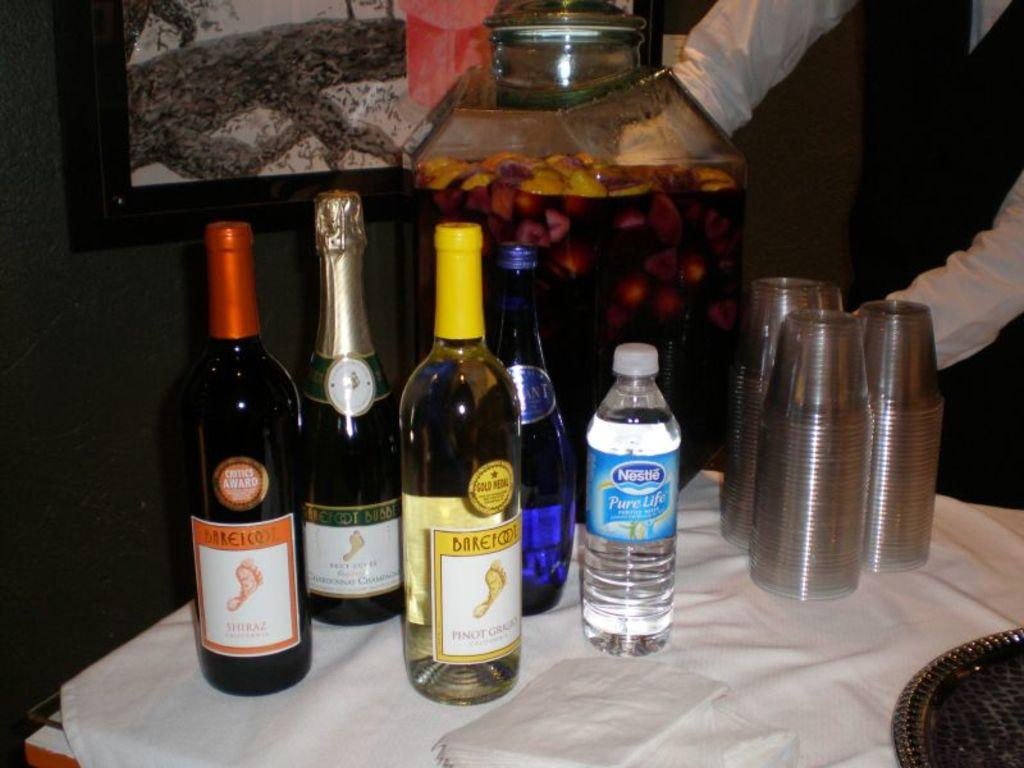What type of bottles can be seen on the table in the image? There are many drink bottles on the table, including water bottles. What else is on the table besides the bottles? There are glasses on the table. Can you describe the person standing in the image? There is a person standing, but no specific details about their appearance or actions are provided. What is covering the table in the image? There is a white cloth on the table. What type of wine is being served in the glasses in the image? There is no wine present in the image; only drink bottles, water bottles, and glasses are visible. What is the acoustics like in the room where the image was taken? The provided facts do not give any information about the acoustics in the room where the image was taken. 